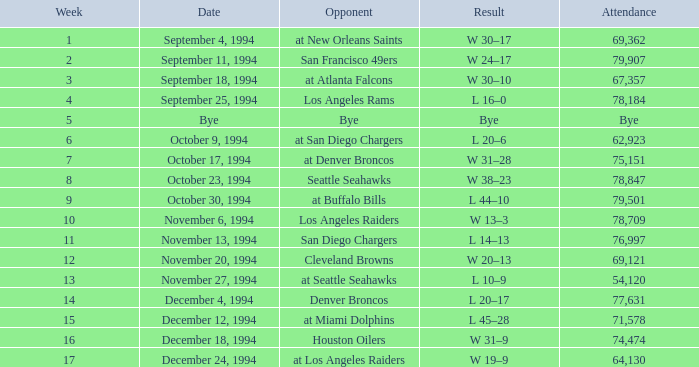What was the score of the Chiefs November 27, 1994 game? L 10–9. 